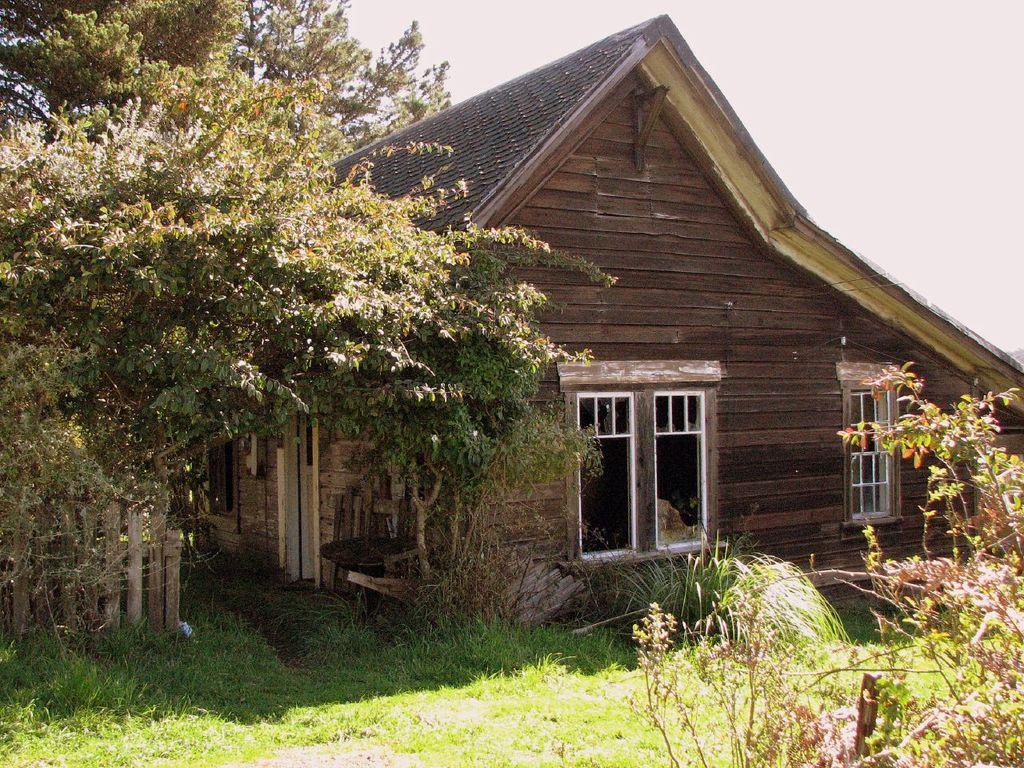In one or two sentences, can you explain what this image depicts? In this image I can see grass ground, plants, trees, a house, windows and on the bottom left side I can see wooden fencing. I can also see the sky in the background. 